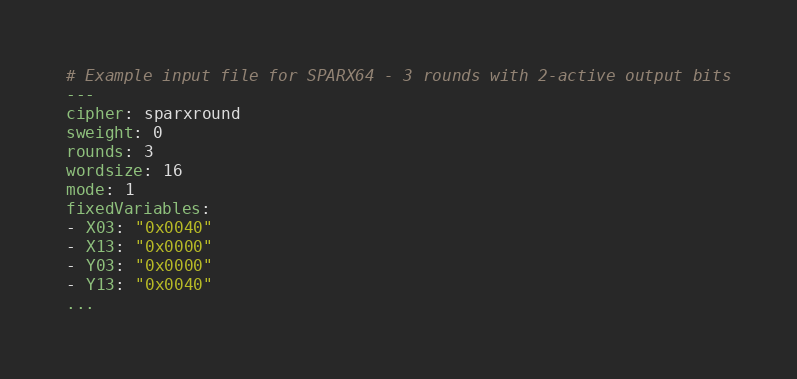<code> <loc_0><loc_0><loc_500><loc_500><_YAML_># Example input file for SPARX64 - 3 rounds with 2-active output bits
---
cipher: sparxround
sweight: 0
rounds: 3
wordsize: 16
mode: 1
fixedVariables:
- X03: "0x0040"
- X13: "0x0000"
- Y03: "0x0000"
- Y13: "0x0040"
...

</code> 